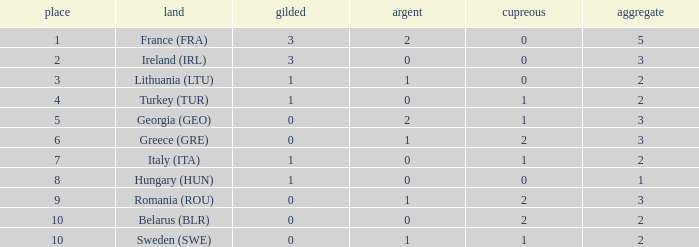What's the total number of bronze medals for Sweden (SWE) having less than 1 gold and silver? 0.0. 